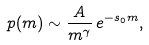<formula> <loc_0><loc_0><loc_500><loc_500>p ( m ) \sim \frac { A } { m ^ { \gamma } } \, e ^ { - s _ { 0 } m } ,</formula> 